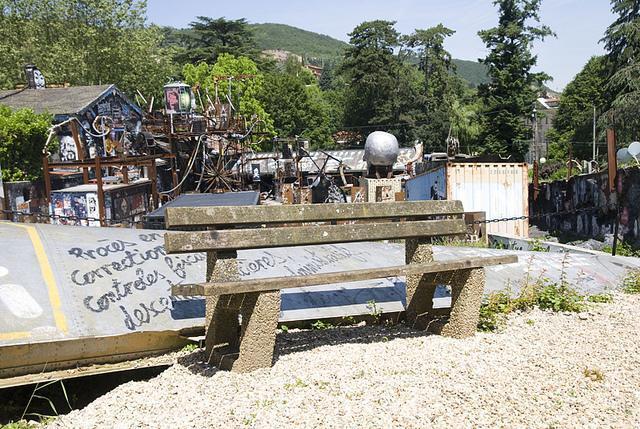How many people are wearing plaid?
Give a very brief answer. 0. 